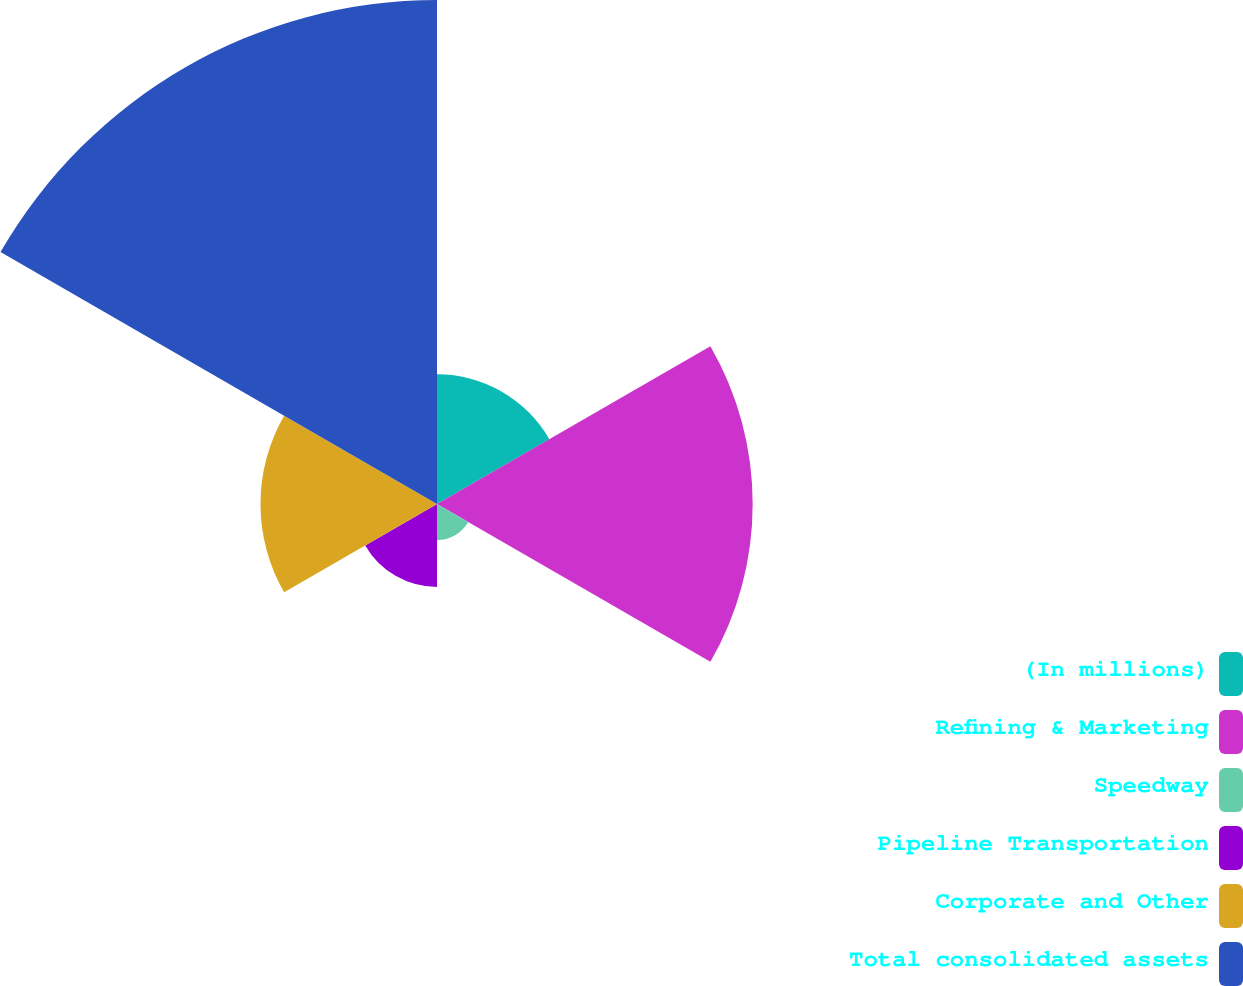<chart> <loc_0><loc_0><loc_500><loc_500><pie_chart><fcel>(In millions)<fcel>Refining & Marketing<fcel>Speedway<fcel>Pipeline Transportation<fcel>Corporate and Other<fcel>Total consolidated assets<nl><fcel>10.42%<fcel>25.36%<fcel>2.9%<fcel>6.66%<fcel>14.18%<fcel>40.49%<nl></chart> 